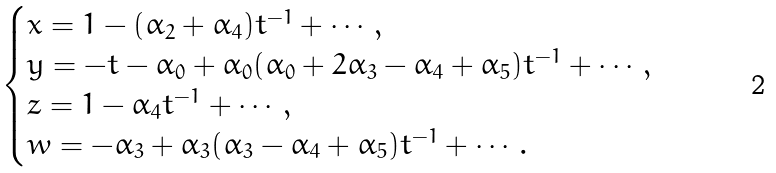Convert formula to latex. <formula><loc_0><loc_0><loc_500><loc_500>\begin{cases} x = 1 - ( \alpha _ { 2 } + \alpha _ { 4 } ) t ^ { - 1 } + \cdots , \\ y = - t - \alpha _ { 0 } + \alpha _ { 0 } ( \alpha _ { 0 } + 2 \alpha _ { 3 } - \alpha _ { 4 } + \alpha _ { 5 } ) t ^ { - 1 } + \cdots , \\ z = 1 - \alpha _ { 4 } t ^ { - 1 } + \cdots , \\ w = - \alpha _ { 3 } + \alpha _ { 3 } ( \alpha _ { 3 } - \alpha _ { 4 } + \alpha _ { 5 } ) t ^ { - 1 } + \cdots . \end{cases}</formula> 